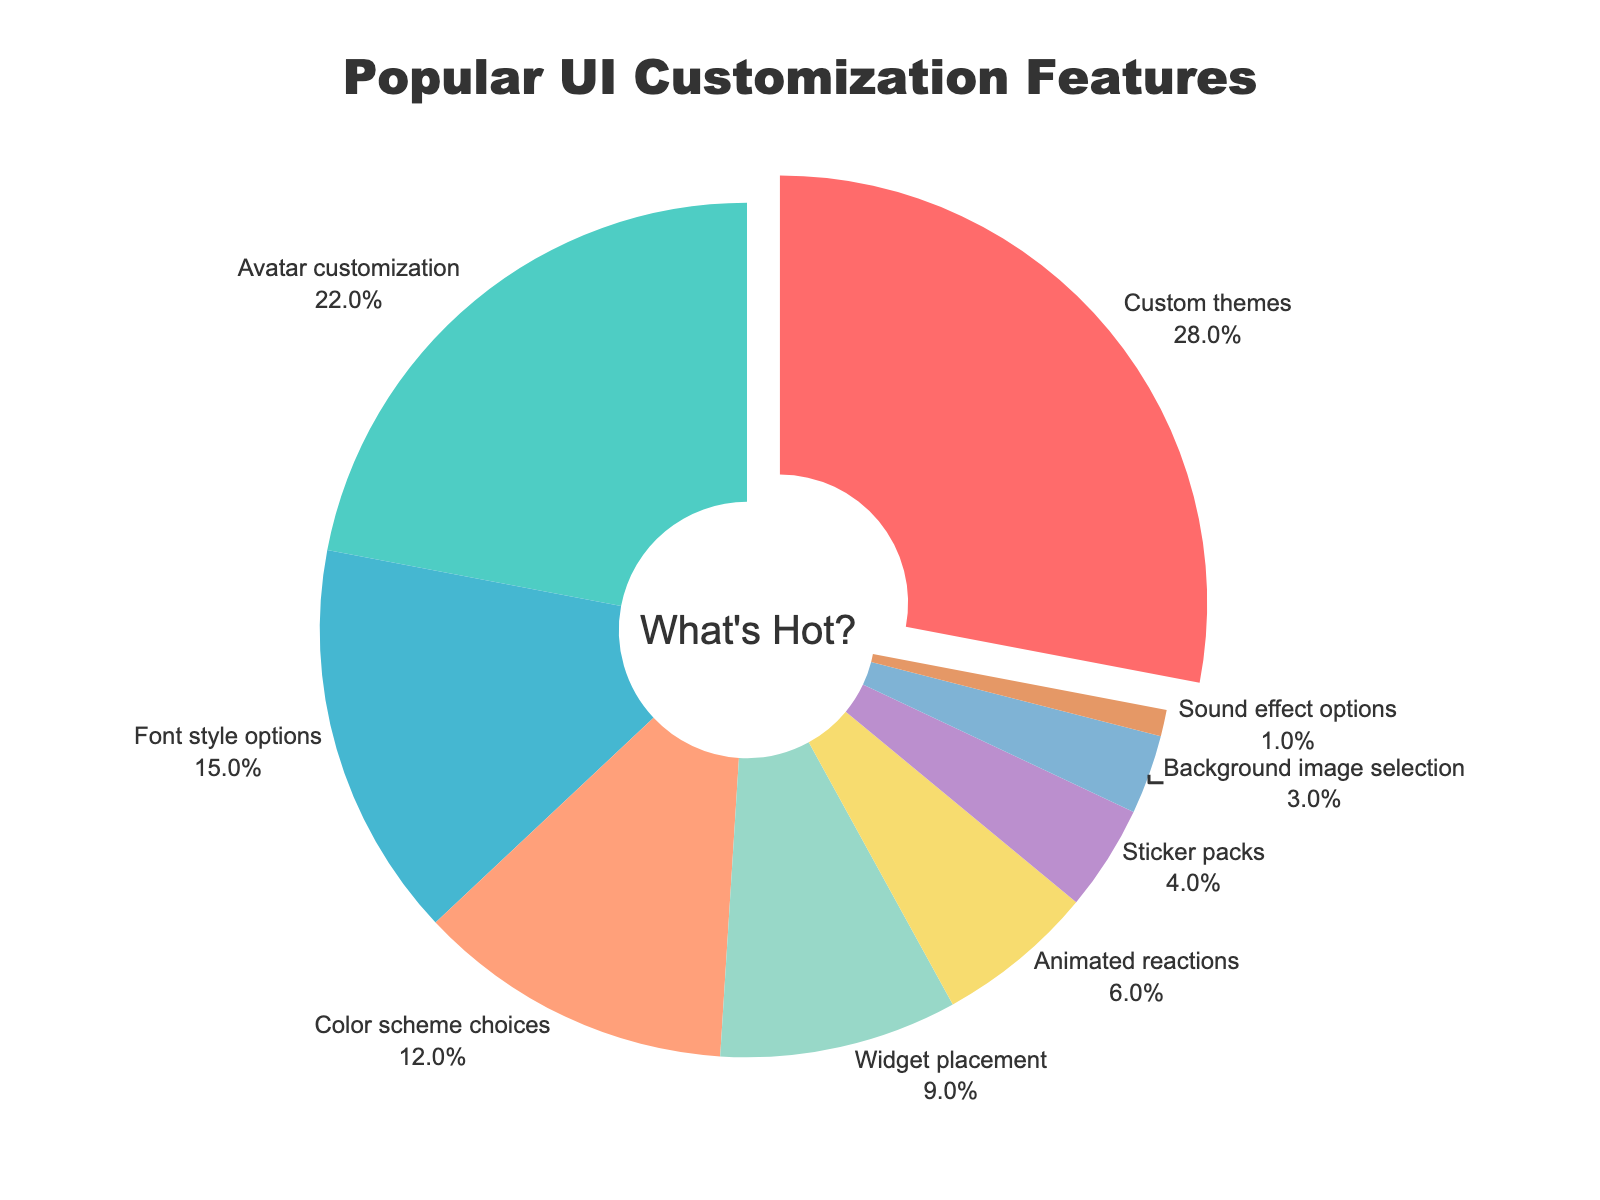What's the most popular customization feature? The slice corresponding to "Custom themes" is pulled out slightly from the pie chart, indicating it is the most popular. The percentage associated is 28%.
Answer: Custom themes What percentage of users prefer avatar customization? The pie chart shows the percentage label for "Avatar customization" as 22%.
Answer: 22% Which feature is less popular: widget placement or animated reactions? By comparing the size and percentage labels of the two slices, we see that "Widget placement" is 9% while "Animated reactions" is 6%. Thus, "Animated reactions" is less popular.
Answer: Animated reactions What is the combined percentage of users who prefer font style options, color scheme choices, and widget placement? These percentages are 15% (Font style options) + 12% (Color scheme choices) + 9% (Widget placement). The combined percentage is 36%.
Answer: 36% How do the popularity percentages of sticker packs and background image selection compare? The percentage for "Sticker packs" is 4%, and for "Background image selection" is 3%. Thus, "Sticker packs" is 1% higher.
Answer: Sticker packs have 1% more than Background image selection What features have percentages that add up to more than half of the total? Looking at the pie chart, we sum the top percentages: "Custom themes" (28%) + "Avatar customization" (22%) + "Font style options" (15%). The total is 65%, which is more than half.
Answer: Custom themes, Avatar customization, Font style options Which feature is represented by the slice with the color closest to yellow? Observing the colors used in the pie chart, the slice that appears closest to yellow corresponds to "Color scheme choices."
Answer: Color scheme choices What is the percentage difference between the most popular and least popular features? The most popular feature is "Custom themes" at 28%, and the least popular is "Sound effect options" at 1%. The difference is 27%.
Answer: 27% Are there more users who prefer color scheme choices or widget placement? According to the chart, "Color scheme choices" has 12% and "Widget placement" has 9%. Therefore, more users prefer "Color scheme choices."
Answer: Color scheme choices 